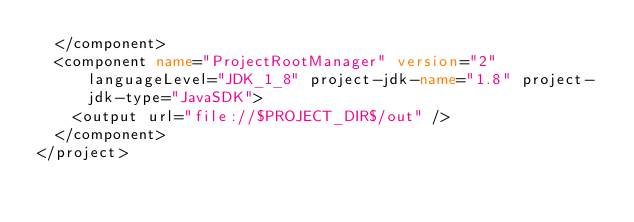Convert code to text. <code><loc_0><loc_0><loc_500><loc_500><_XML_>  </component>
  <component name="ProjectRootManager" version="2" languageLevel="JDK_1_8" project-jdk-name="1.8" project-jdk-type="JavaSDK">
    <output url="file://$PROJECT_DIR$/out" />
  </component>
</project></code> 